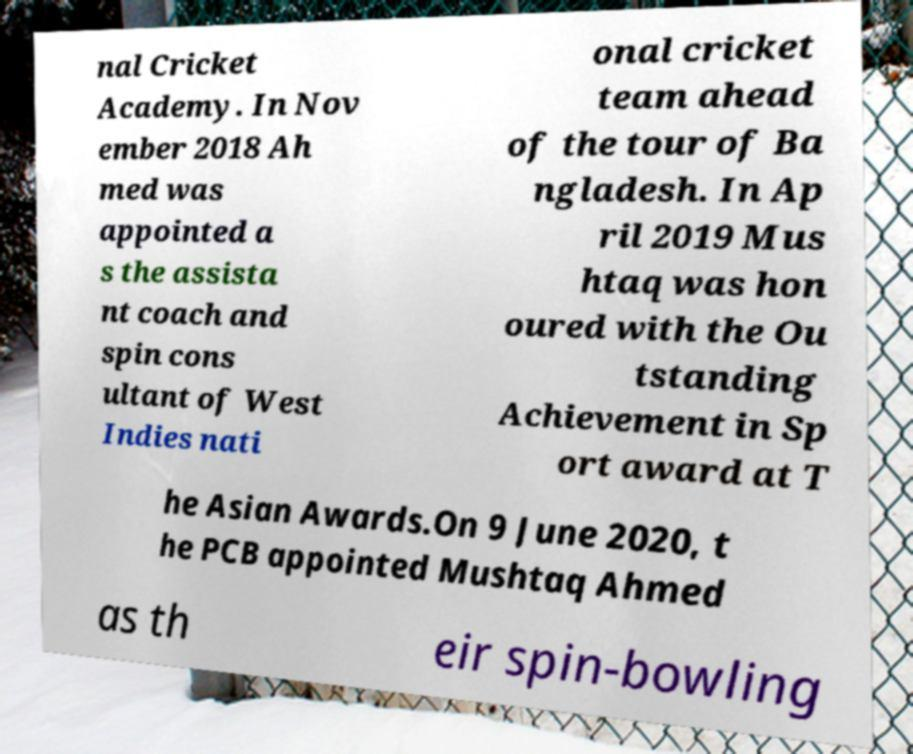Please identify and transcribe the text found in this image. nal Cricket Academy. In Nov ember 2018 Ah med was appointed a s the assista nt coach and spin cons ultant of West Indies nati onal cricket team ahead of the tour of Ba ngladesh. In Ap ril 2019 Mus htaq was hon oured with the Ou tstanding Achievement in Sp ort award at T he Asian Awards.On 9 June 2020, t he PCB appointed Mushtaq Ahmed as th eir spin-bowling 